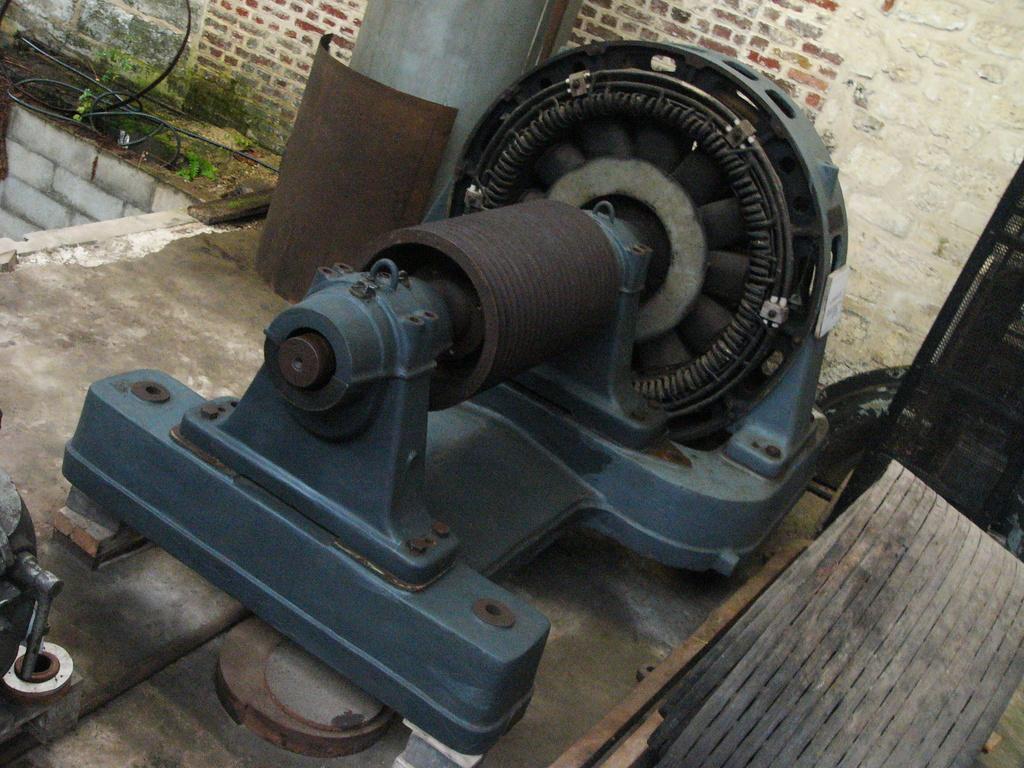How would you summarize this image in a sentence or two? In this image we can see the rotor. We can also see the land, wires and also the brick wall. 